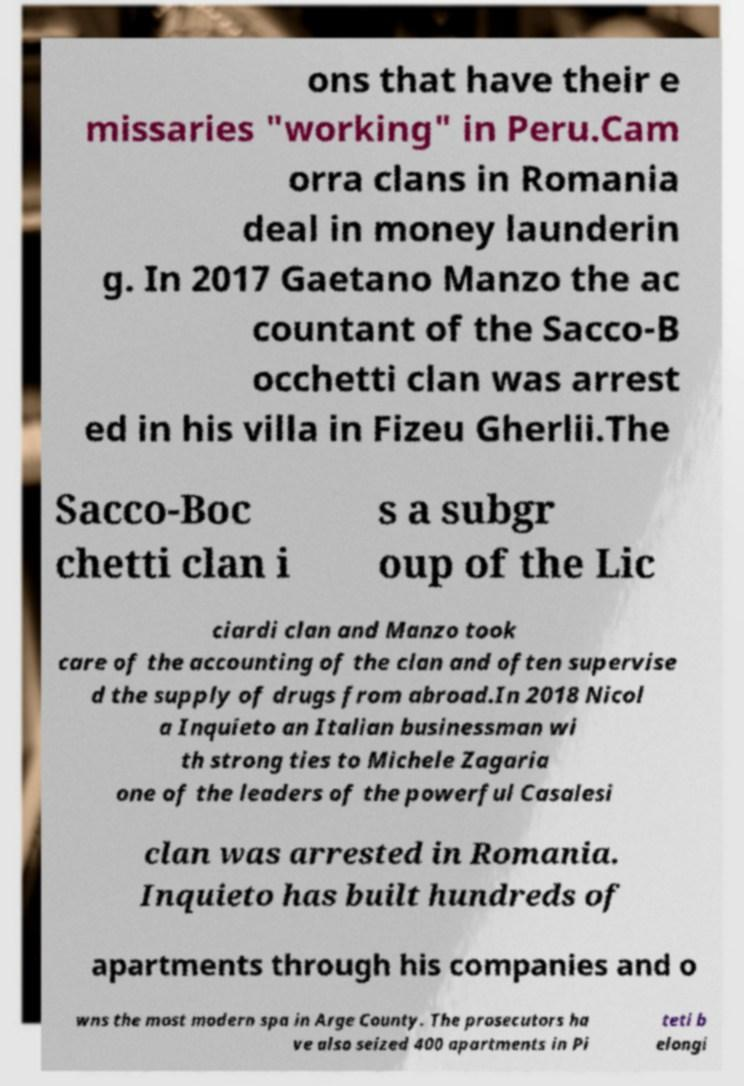Please read and relay the text visible in this image. What does it say? ons that have their e missaries "working" in Peru.Cam orra clans in Romania deal in money launderin g. In 2017 Gaetano Manzo the ac countant of the Sacco-B occhetti clan was arrest ed in his villa in Fizeu Gherlii.The Sacco-Boc chetti clan i s a subgr oup of the Lic ciardi clan and Manzo took care of the accounting of the clan and often supervise d the supply of drugs from abroad.In 2018 Nicol a Inquieto an Italian businessman wi th strong ties to Michele Zagaria one of the leaders of the powerful Casalesi clan was arrested in Romania. Inquieto has built hundreds of apartments through his companies and o wns the most modern spa in Arge County. The prosecutors ha ve also seized 400 apartments in Pi teti b elongi 